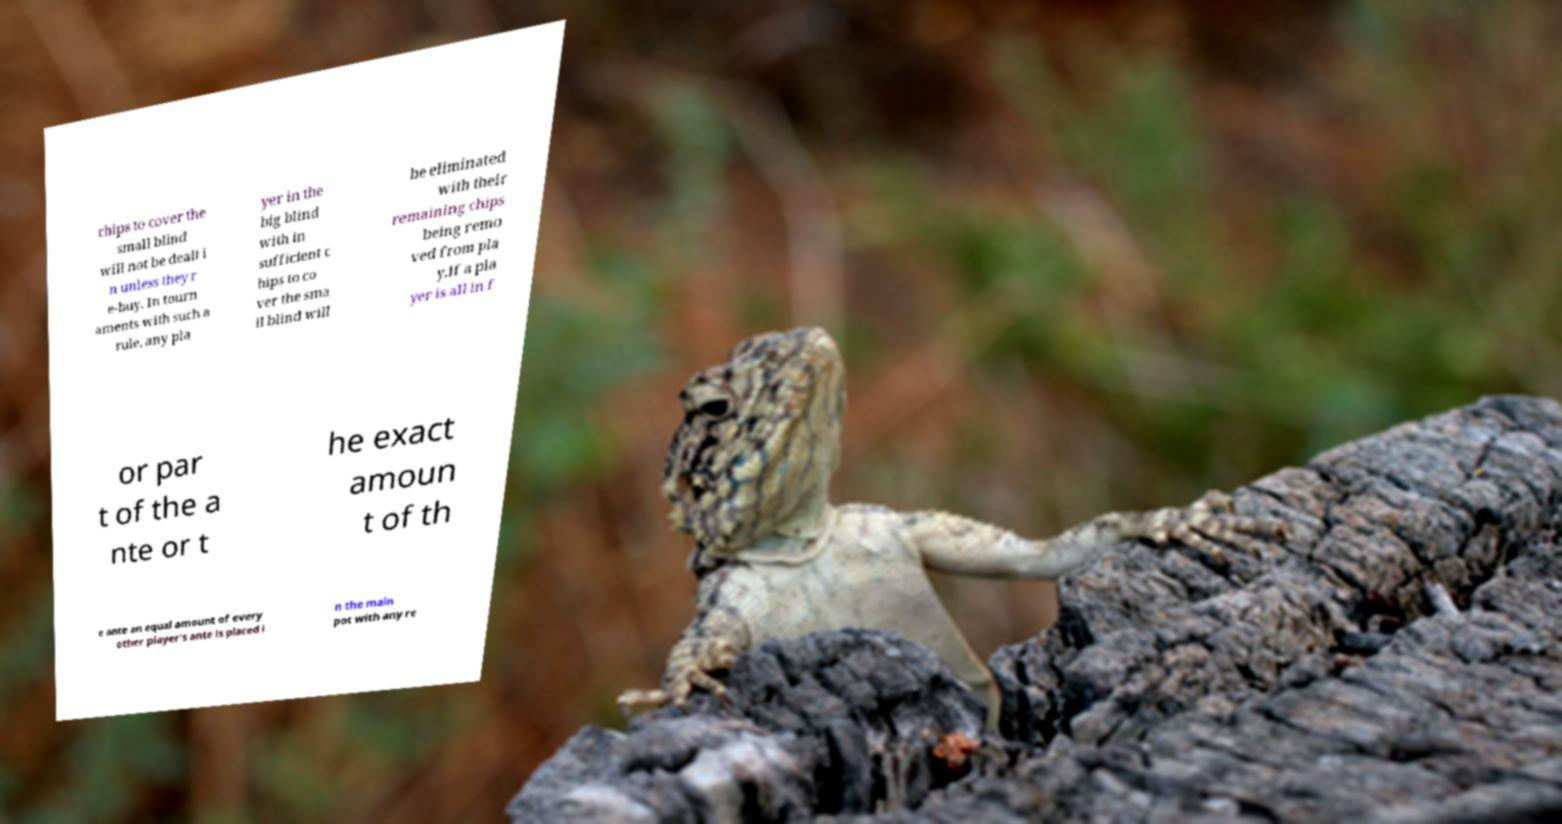There's text embedded in this image that I need extracted. Can you transcribe it verbatim? chips to cover the small blind will not be dealt i n unless they r e-buy. In tourn aments with such a rule, any pla yer in the big blind with in sufficient c hips to co ver the sma ll blind will be eliminated with their remaining chips being remo ved from pla y.If a pla yer is all in f or par t of the a nte or t he exact amoun t of th e ante an equal amount of every other player's ante is placed i n the main pot with any re 